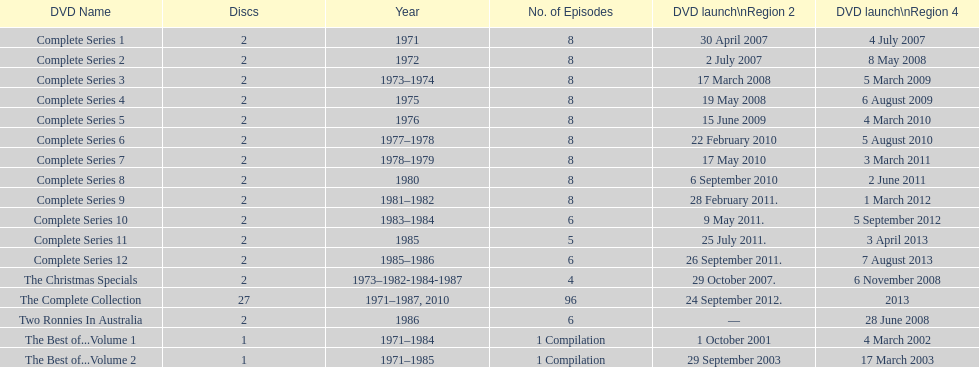What comes immediately after complete series 11? Complete Series 12. 